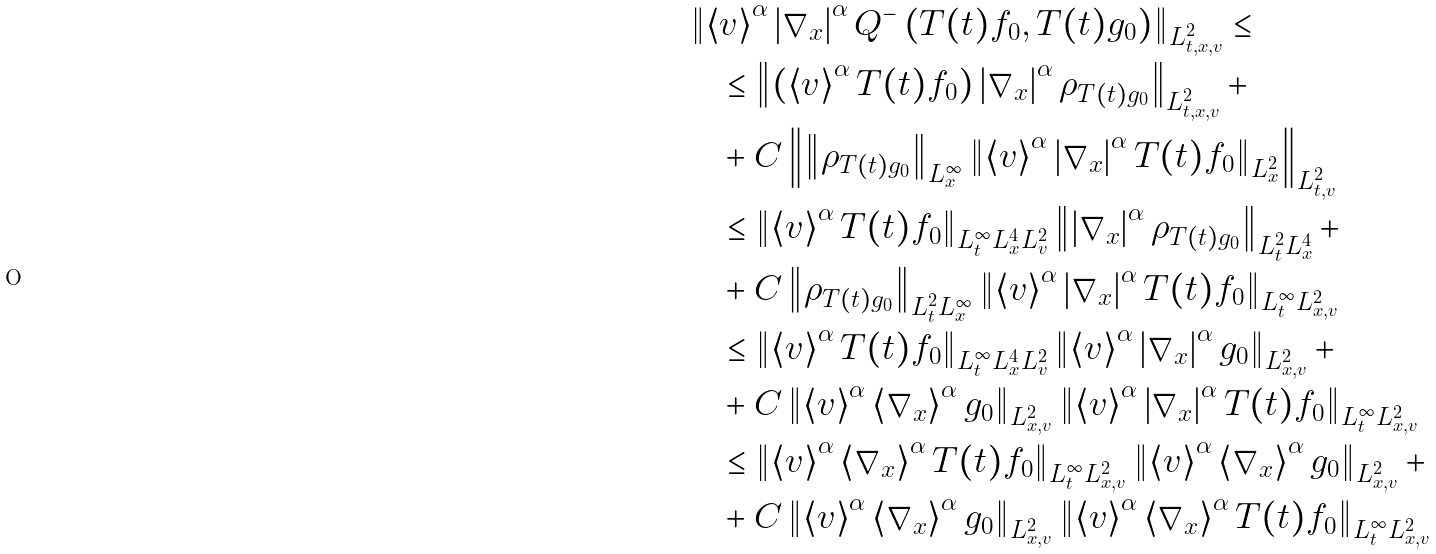Convert formula to latex. <formula><loc_0><loc_0><loc_500><loc_500>& \left \| \left < v \right > ^ { \alpha } \left | \nabla _ { x } \right | ^ { \alpha } Q ^ { - } \left ( T ( t ) f _ { 0 } , T ( t ) g _ { 0 } \right ) \right \| _ { L ^ { 2 } _ { t , x , v } } \leq \\ & \quad \leq \left \| \left ( \left < v \right > ^ { \alpha } T ( t ) f _ { 0 } \right ) \left | \nabla _ { x } \right | ^ { \alpha } \rho _ { T ( t ) g _ { 0 } } \right \| _ { L ^ { 2 } _ { t , x , v } } + \\ & \quad + C \left \| \left \| \rho _ { T ( t ) g _ { 0 } } \right \| _ { L ^ { \infty } _ { x } } \left \| \left < v \right > ^ { \alpha } \left | \nabla _ { x } \right | ^ { \alpha } T ( t ) f _ { 0 } \right \| _ { L ^ { 2 } _ { x } } \right \| _ { L ^ { 2 } _ { t , v } } \\ & \quad \leq \left \| \left < v \right > ^ { \alpha } T ( t ) f _ { 0 } \right \| _ { L ^ { \infty } _ { t } L ^ { 4 } _ { x } L ^ { 2 } _ { v } } \left \| \left | \nabla _ { x } \right | ^ { \alpha } \rho _ { T ( t ) g _ { 0 } } \right \| _ { L ^ { 2 } _ { t } L ^ { 4 } _ { x } } + \\ & \quad + C \left \| \rho _ { T ( t ) g _ { 0 } } \right \| _ { L ^ { 2 } _ { t } L ^ { \infty } _ { x } } \left \| \left < v \right > ^ { \alpha } \left | \nabla _ { x } \right | ^ { \alpha } T ( t ) f _ { 0 } \right \| _ { L ^ { \infty } _ { t } L ^ { 2 } _ { x , v } } \\ & \quad \leq \left \| \left < v \right > ^ { \alpha } T ( t ) f _ { 0 } \right \| _ { L ^ { \infty } _ { t } L ^ { 4 } _ { x } L ^ { 2 } _ { v } } \left \| \left < v \right > ^ { \alpha } \left | \nabla _ { x } \right | ^ { \alpha } g _ { 0 } \right \| _ { L ^ { 2 } _ { x , v } } + \\ & \quad + C \left \| \left < v \right > ^ { \alpha } \left < \nabla _ { x } \right > ^ { \alpha } g _ { 0 } \right \| _ { L ^ { 2 } _ { x , v } } \left \| \left < v \right > ^ { \alpha } \left | \nabla _ { x } \right | ^ { \alpha } T ( t ) f _ { 0 } \right \| _ { L ^ { \infty } _ { t } L ^ { 2 } _ { x , v } } \\ & \quad \leq \left \| \left < v \right > ^ { \alpha } \left < \nabla _ { x } \right > ^ { \alpha } T ( t ) f _ { 0 } \right \| _ { L ^ { \infty } _ { t } L ^ { 2 } _ { x , v } } \left \| \left < v \right > ^ { \alpha } \left < \nabla _ { x } \right > ^ { \alpha } g _ { 0 } \right \| _ { L ^ { 2 } _ { x , v } } + \\ & \quad + C \left \| \left < v \right > ^ { \alpha } \left < \nabla _ { x } \right > ^ { \alpha } g _ { 0 } \right \| _ { L ^ { 2 } _ { x , v } } \left \| \left < v \right > ^ { \alpha } \left < \nabla _ { x } \right > ^ { \alpha } T ( t ) f _ { 0 } \right \| _ { L ^ { \infty } _ { t } L ^ { 2 } _ { x , v } } \\</formula> 